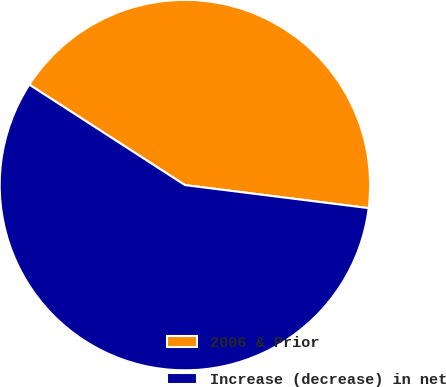Convert chart to OTSL. <chart><loc_0><loc_0><loc_500><loc_500><pie_chart><fcel>2006 & Prior<fcel>Increase (decrease) in net<nl><fcel>42.86%<fcel>57.14%<nl></chart> 